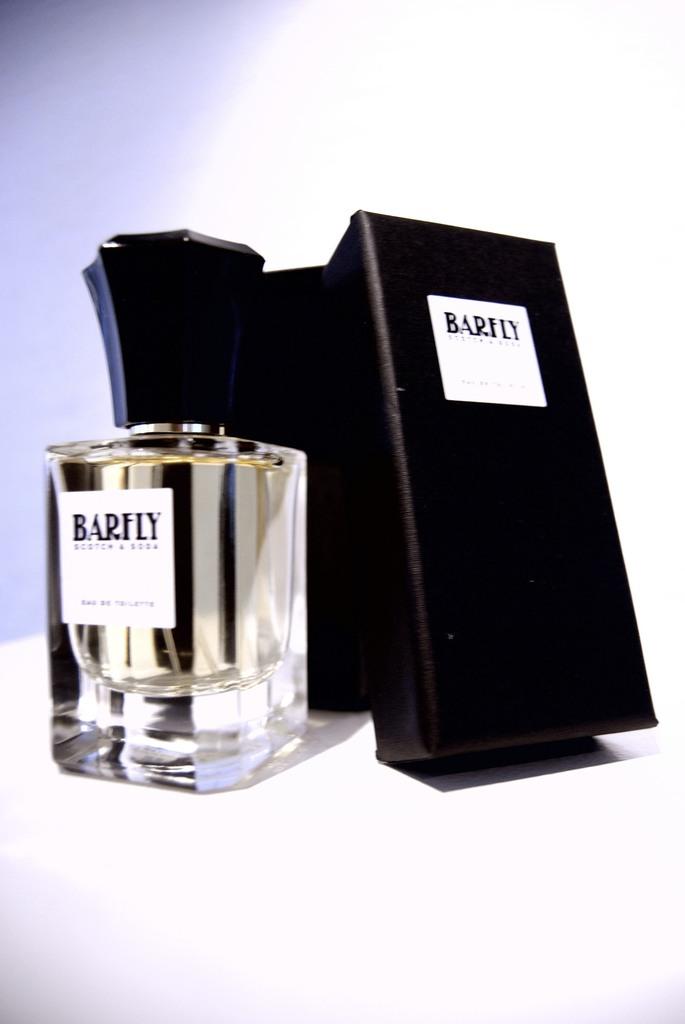What is the name of the product contained in the bottle?
Make the answer very short. Barfly. 